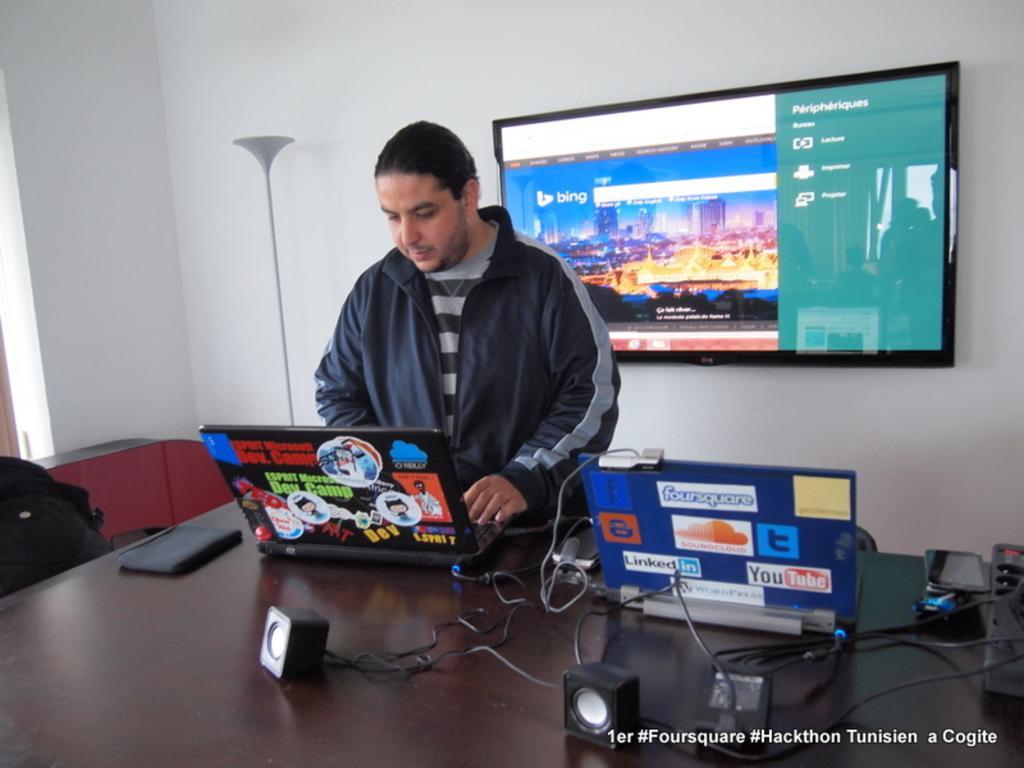In one or two sentences, can you explain what this image depicts? In this image I can see a table where we can see a man standing and few other objects beside that, also there is a TV screen on the wall. 